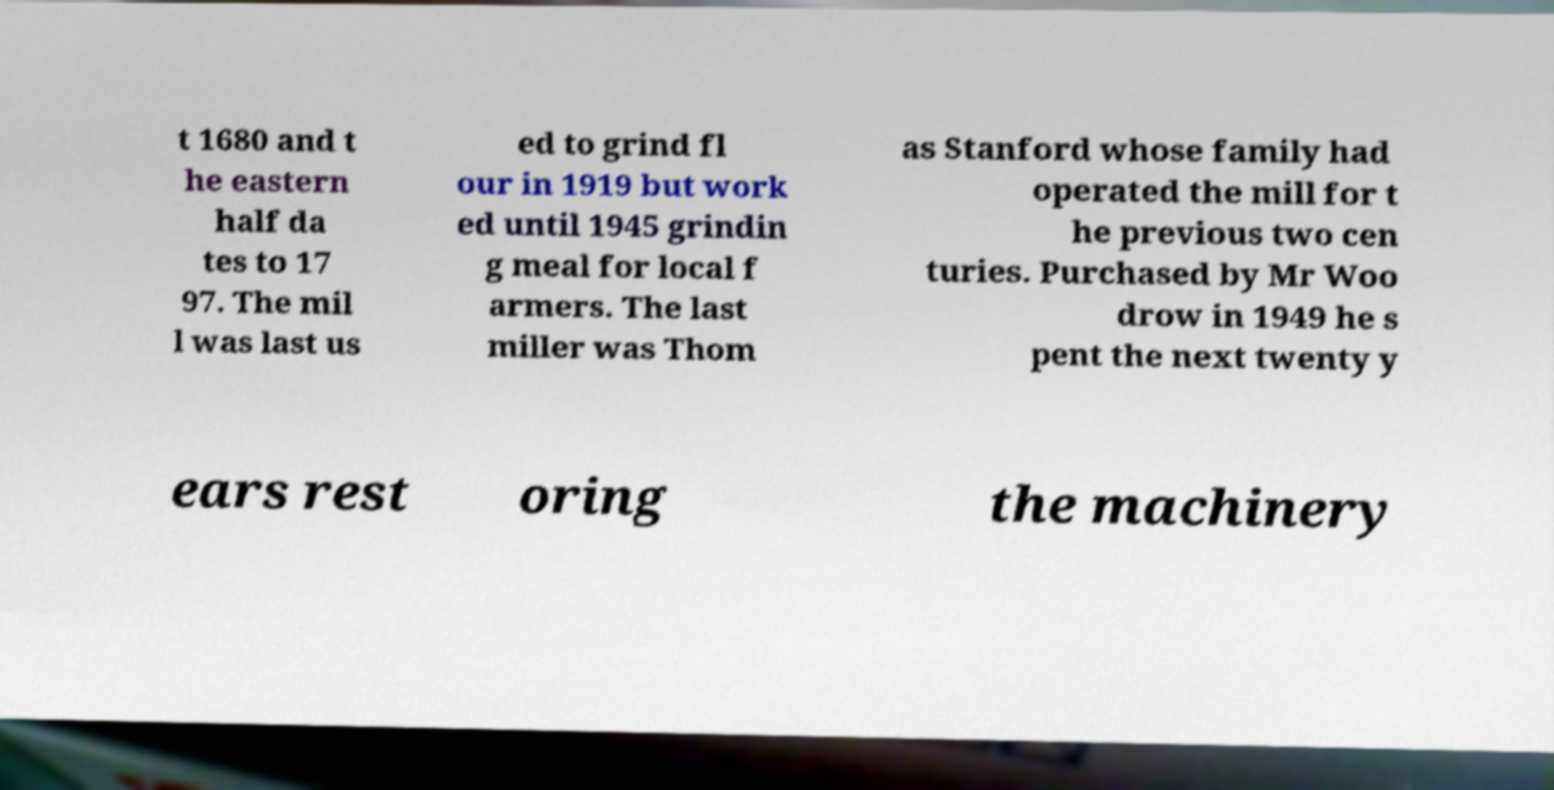For documentation purposes, I need the text within this image transcribed. Could you provide that? t 1680 and t he eastern half da tes to 17 97. The mil l was last us ed to grind fl our in 1919 but work ed until 1945 grindin g meal for local f armers. The last miller was Thom as Stanford whose family had operated the mill for t he previous two cen turies. Purchased by Mr Woo drow in 1949 he s pent the next twenty y ears rest oring the machinery 